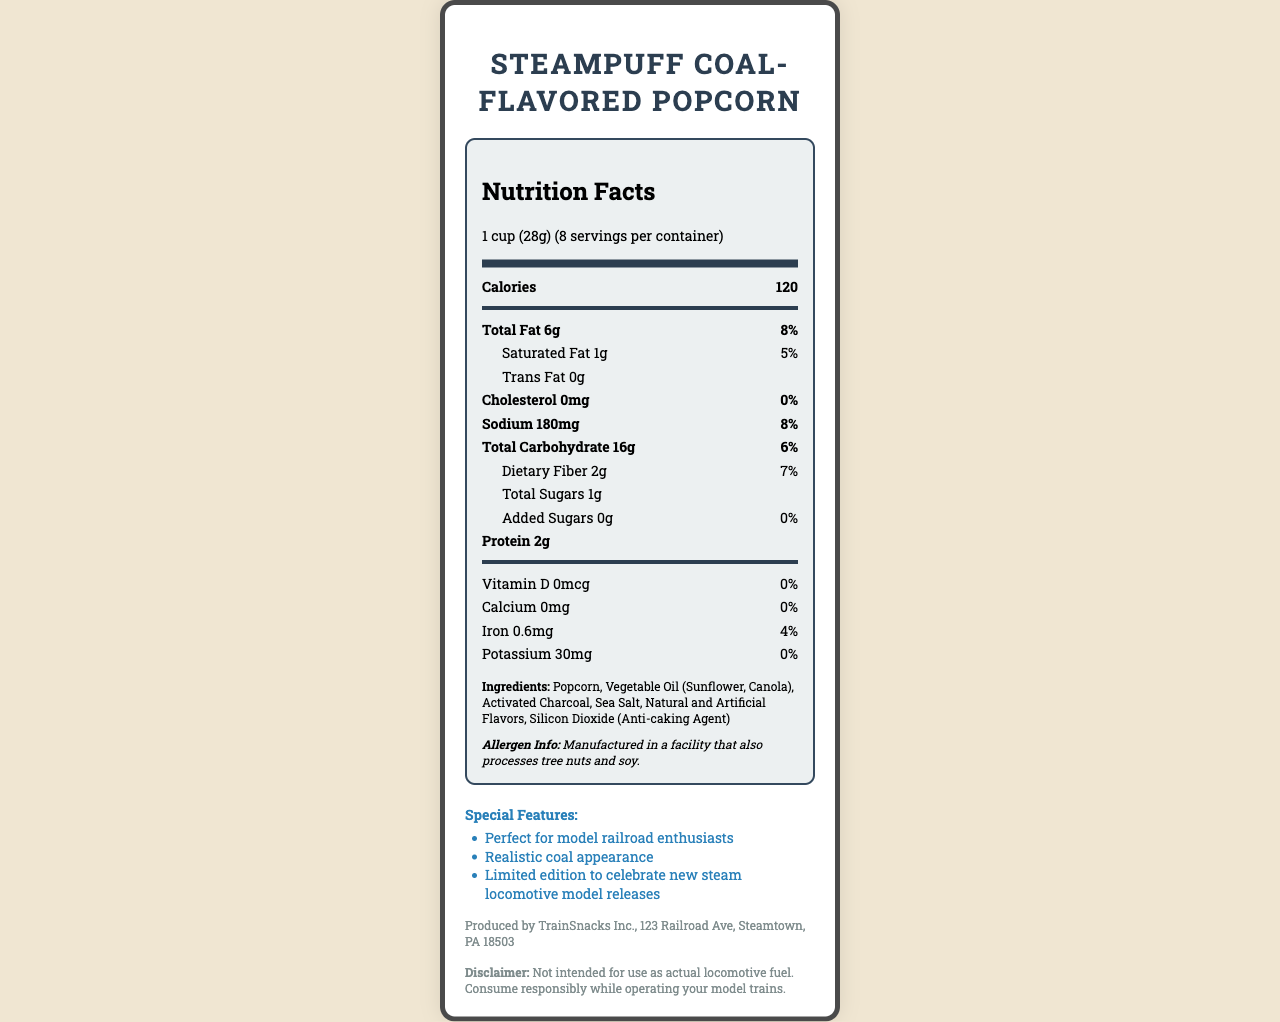what is the product name? The product name is displayed prominently at the top of the document.
Answer: SteamPuff Coal-Flavored Popcorn what is the serving size? The serving size is stated as "1 cup (28g)" directly under the product name.
Answer: 1 cup (28g) how many servings are in the container? The servings per container are listed as 8 in the serving information section.
Answer: 8 how many calories are in one serving? The number of calories per serving is shown as 120 in the main nutrient section.
Answer: 120 what are the total grams of fat in one serving? The total fat amount is listed as 6g in the main nutrient section.
Answer: 6g how much dietary fiber is in each serving? The document lists dietary fiber as 2g in the sub-nutrient section under total carbohydrate.
Answer: 2g how much iron does one serving contain? The amount of iron per serving is provided as 0.6mg in the nutrient details section.
Answer: 0.6mg what is the amount of sodium per serving? The sodium content is listed as 180mg in the main nutrient section.
Answer: 180mg what ingredients are used in the popcorn? The ingredients are enumerated in the ingredients section of the document.
Answer: Popcorn, Vegetable Oil (Sunflower, Canola), Activated Charcoal, Sea Salt, Natural and Artificial Flavors, Silicon Dioxide (Anti-caking Agent) Which of the following is NOT listed as a special feature of the product? A. Realistic coal appearance B. Gluten-free C. Perfect for model railroad enthusiasts The special features listed are "Perfect for model railroad enthusiasts," "Realistic coal appearance," and "Limited edition to celebrate new steam locomotive model releases." Gluten-free is not mentioned.
Answer: B What allergen information is provided? A. Contains dairy B. Contains gluten C. Manufactured in a facility that processes tree nuts and soy D. Contains peanuts The allergen information states that it is manufactured in a facility that also processes tree nuts and soy.
Answer: C does the product contain any added sugars? The document lists added sugars as 0g, indicating no added sugars.
Answer: No is this product intended for use as an actual locomotive fuel? The disclaimer states, "Not intended for use as actual locomotive fuel."
Answer: No Summarize the main features and nutritional aspects of the product The summary captures the key points about the product's unique theme, nutritional details, ingredients, allergen information, and its purpose as a themed snack, highlighting both its novelty and nutritional content.
Answer: The SteamPuff Coal-Flavored Popcorn is a specialty snack designed for model railroad enthusiasts, featuring a realistic coal appearance and limited-edition release. It offers 120 calories per serving with 6g of total fat, 16g of total carbohydrates, and 2g of protein. Notable ingredients include popcorn, vegetable oil, activated charcoal, and sea salt. The product is manufactured in a facility that processes tree nuts and soy, and it is clearly not meant for use as actual locomotive fuel. how much vitamin C is present in this product? The document does not provide any information about the vitamin C content.
Answer: Not enough information 